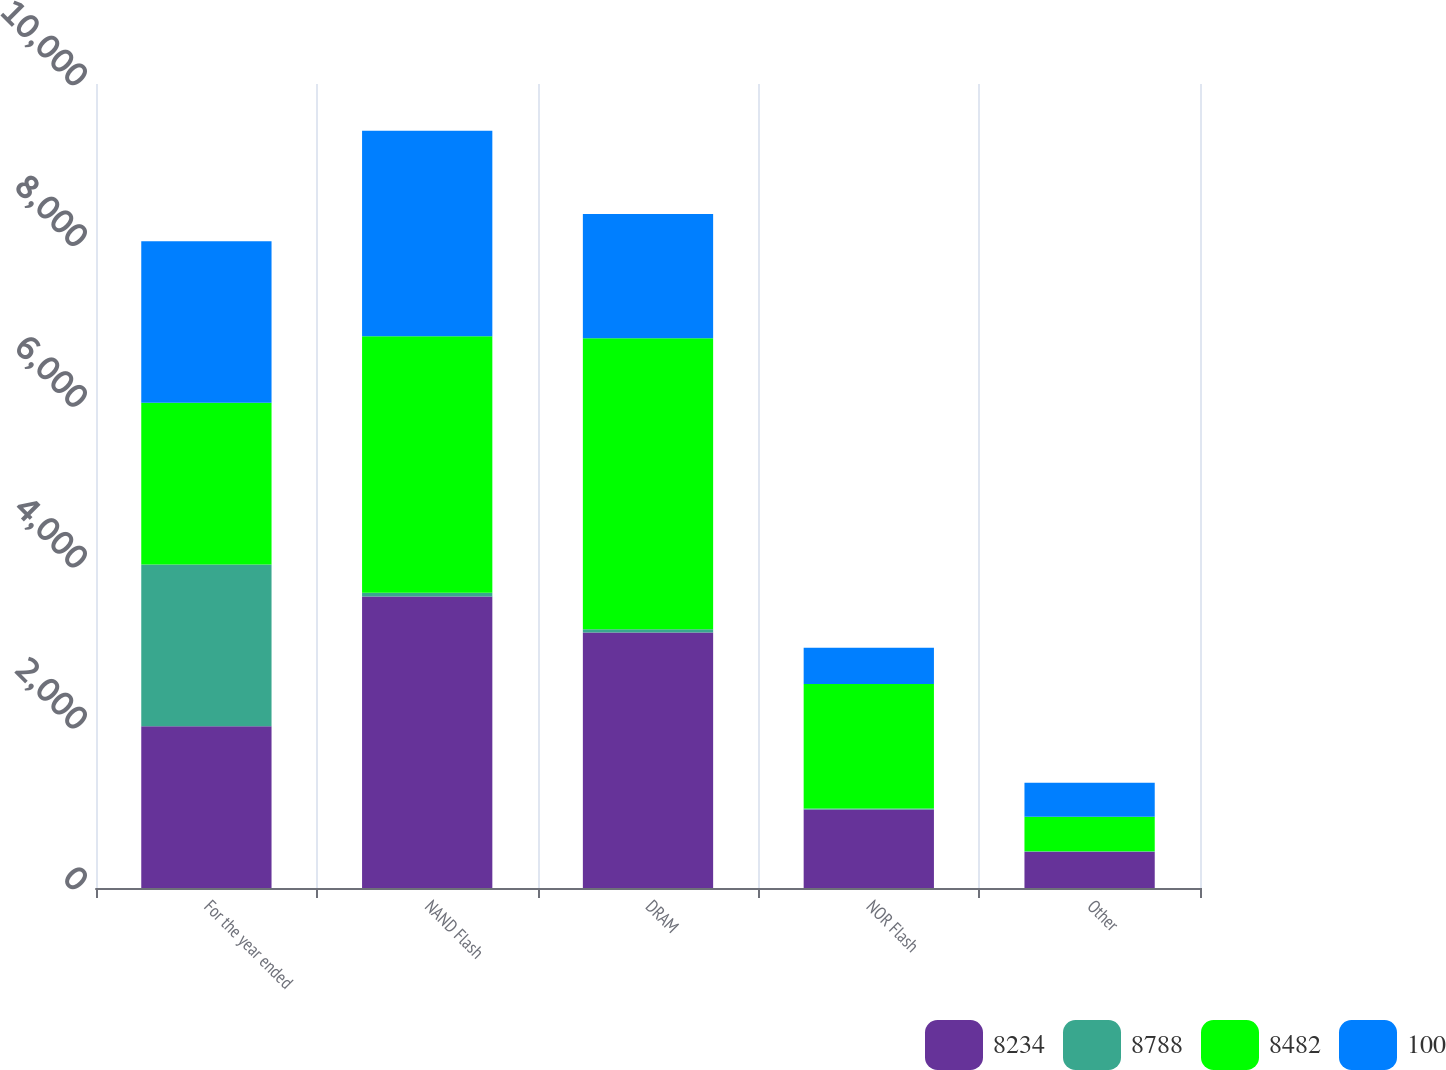Convert chart. <chart><loc_0><loc_0><loc_500><loc_500><stacked_bar_chart><ecel><fcel>For the year ended<fcel>NAND Flash<fcel>DRAM<fcel>NOR Flash<fcel>Other<nl><fcel>8234<fcel>2012<fcel>3627<fcel>3178<fcel>977<fcel>452<nl><fcel>8788<fcel>2012<fcel>44<fcel>39<fcel>12<fcel>5<nl><fcel>8482<fcel>2011<fcel>3193<fcel>3620<fcel>1547<fcel>428<nl><fcel>100<fcel>2010<fcel>2555<fcel>1547<fcel>451<fcel>424<nl></chart> 